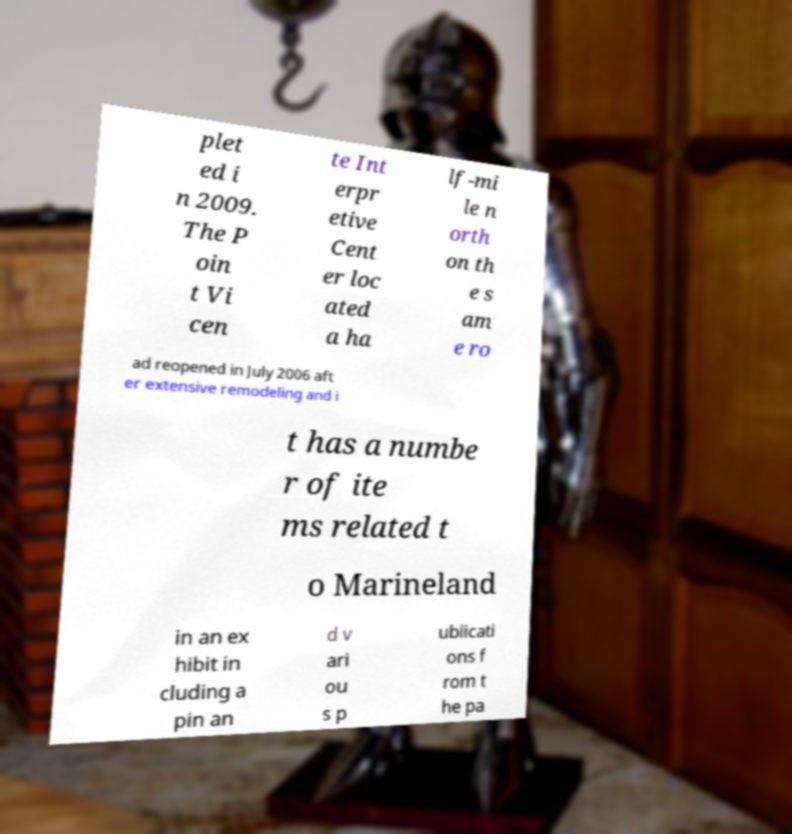I need the written content from this picture converted into text. Can you do that? plet ed i n 2009. The P oin t Vi cen te Int erpr etive Cent er loc ated a ha lf-mi le n orth on th e s am e ro ad reopened in July 2006 aft er extensive remodeling and i t has a numbe r of ite ms related t o Marineland in an ex hibit in cluding a pin an d v ari ou s p ublicati ons f rom t he pa 